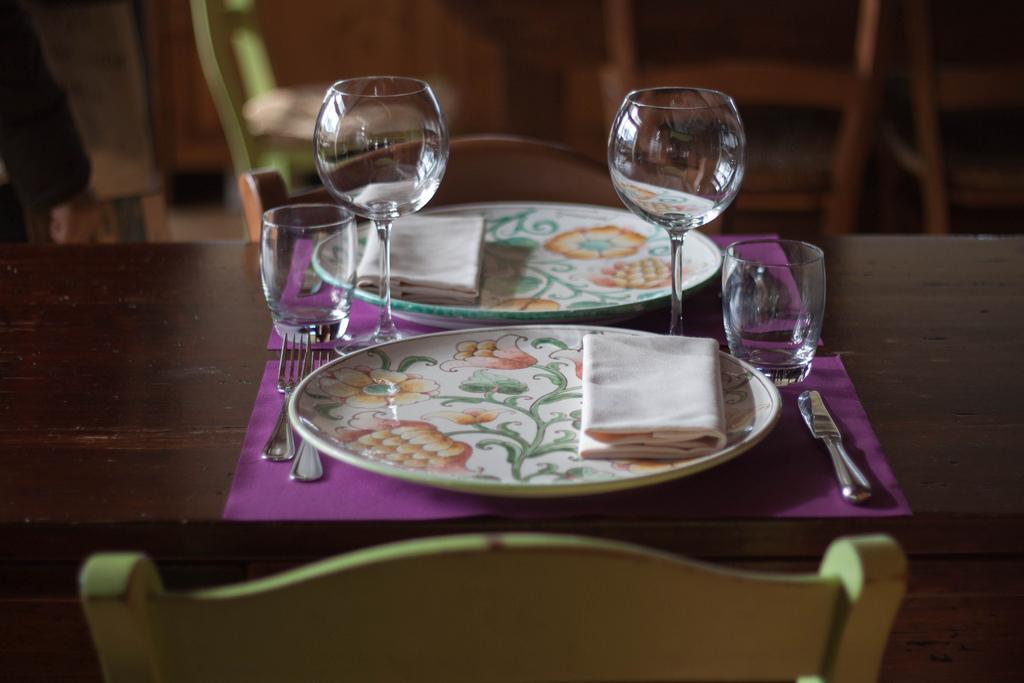Could you give a brief overview of what you see in this image? This is the picture of a table on which there are two plates, glasses, cups and some spoons and also there are some chairs. 